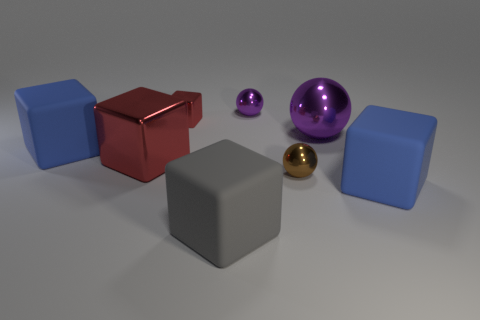There is a tiny shiny block; does it have the same color as the large rubber cube that is right of the large gray thing?
Your answer should be very brief. No. What is the material of the big thing that is both in front of the brown sphere and to the right of the big gray thing?
Your answer should be very brief. Rubber. Are there any cyan matte spheres of the same size as the gray matte cube?
Your answer should be very brief. No. What is the material of the purple object that is the same size as the gray matte object?
Your answer should be compact. Metal. There is a small brown metal object; how many large objects are right of it?
Ensure brevity in your answer.  2. Does the big blue object that is behind the big red metal cube have the same shape as the large purple metallic object?
Offer a terse response. No. Are there any small cyan shiny objects that have the same shape as the tiny brown object?
Provide a succinct answer. No. What is the material of the big cube that is the same color as the small shiny block?
Provide a succinct answer. Metal. There is a big blue matte thing left of the red metal thing in front of the tiny red thing; what is its shape?
Make the answer very short. Cube. What number of blue objects have the same material as the large gray thing?
Keep it short and to the point. 2. 